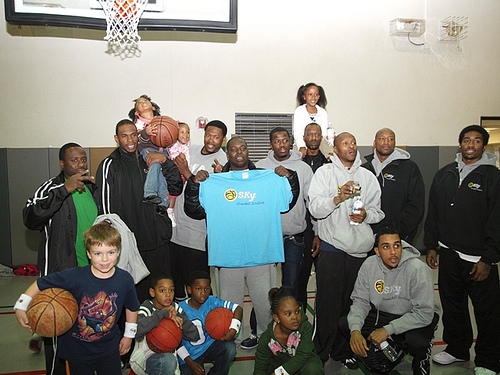<image>
Can you confirm if the light is to the right of the box? Yes. From this viewpoint, the light is positioned to the right side relative to the box. 